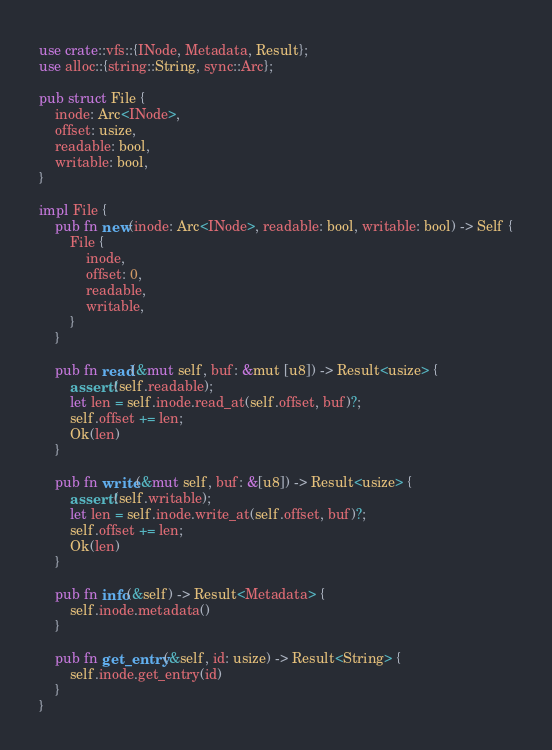<code> <loc_0><loc_0><loc_500><loc_500><_Rust_>use crate::vfs::{INode, Metadata, Result};
use alloc::{string::String, sync::Arc};

pub struct File {
    inode: Arc<INode>,
    offset: usize,
    readable: bool,
    writable: bool,
}

impl File {
    pub fn new(inode: Arc<INode>, readable: bool, writable: bool) -> Self {
        File {
            inode,
            offset: 0,
            readable,
            writable,
        }
    }

    pub fn read(&mut self, buf: &mut [u8]) -> Result<usize> {
        assert!(self.readable);
        let len = self.inode.read_at(self.offset, buf)?;
        self.offset += len;
        Ok(len)
    }

    pub fn write(&mut self, buf: &[u8]) -> Result<usize> {
        assert!(self.writable);
        let len = self.inode.write_at(self.offset, buf)?;
        self.offset += len;
        Ok(len)
    }

    pub fn info(&self) -> Result<Metadata> {
        self.inode.metadata()
    }

    pub fn get_entry(&self, id: usize) -> Result<String> {
        self.inode.get_entry(id)
    }
}
</code> 